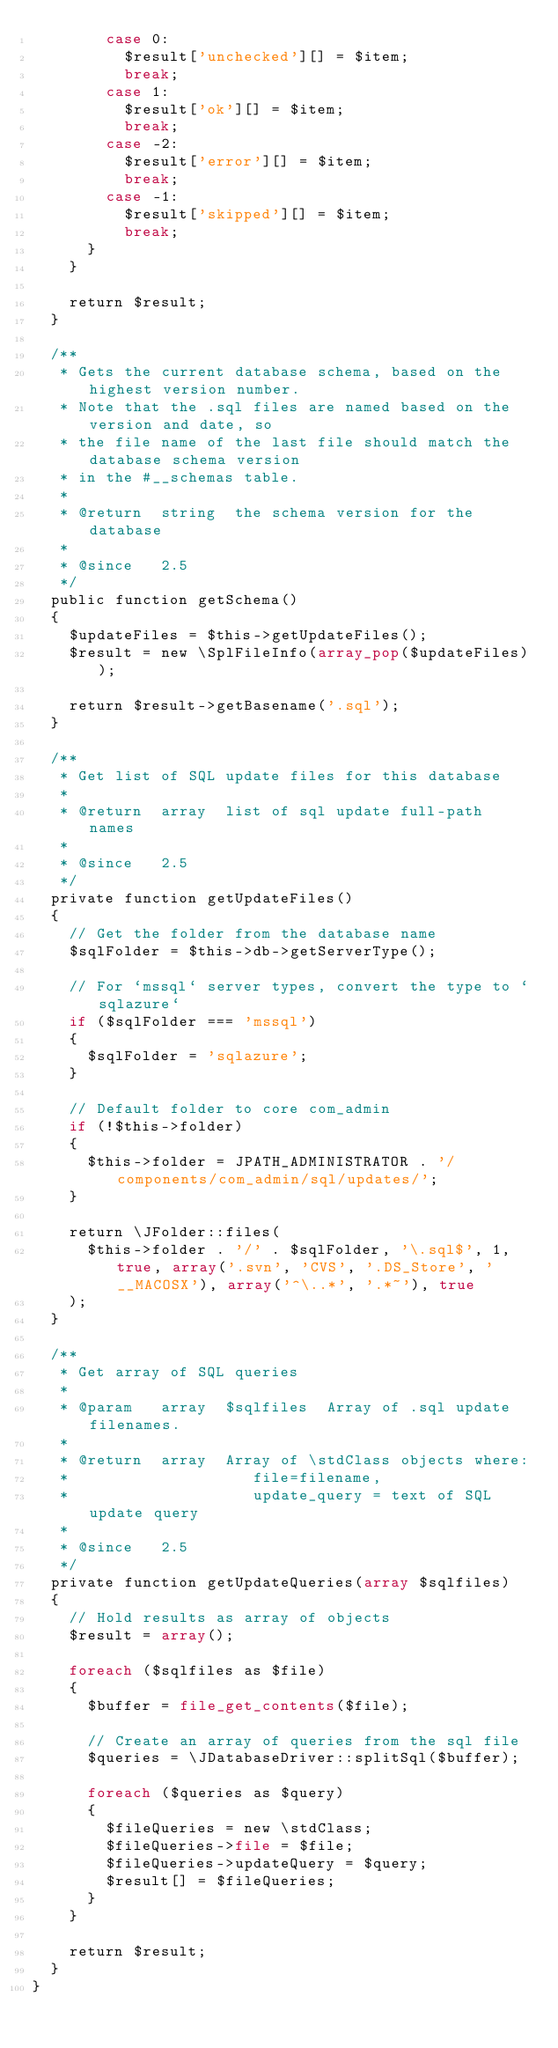<code> <loc_0><loc_0><loc_500><loc_500><_PHP_>				case 0:
					$result['unchecked'][] = $item;
					break;
				case 1:
					$result['ok'][] = $item;
					break;
				case -2:
					$result['error'][] = $item;
					break;
				case -1:
					$result['skipped'][] = $item;
					break;
			}
		}

		return $result;
	}

	/**
	 * Gets the current database schema, based on the highest version number.
	 * Note that the .sql files are named based on the version and date, so
	 * the file name of the last file should match the database schema version
	 * in the #__schemas table.
	 *
	 * @return  string  the schema version for the database
	 *
	 * @since   2.5
	 */
	public function getSchema()
	{
		$updateFiles = $this->getUpdateFiles();
		$result = new \SplFileInfo(array_pop($updateFiles));

		return $result->getBasename('.sql');
	}

	/**
	 * Get list of SQL update files for this database
	 *
	 * @return  array  list of sql update full-path names
	 *
	 * @since   2.5
	 */
	private function getUpdateFiles()
	{
		// Get the folder from the database name
		$sqlFolder = $this->db->getServerType();

		// For `mssql` server types, convert the type to `sqlazure`
		if ($sqlFolder === 'mssql')
		{
			$sqlFolder = 'sqlazure';
		}

		// Default folder to core com_admin
		if (!$this->folder)
		{
			$this->folder = JPATH_ADMINISTRATOR . '/components/com_admin/sql/updates/';
		}

		return \JFolder::files(
			$this->folder . '/' . $sqlFolder, '\.sql$', 1, true, array('.svn', 'CVS', '.DS_Store', '__MACOSX'), array('^\..*', '.*~'), true
		);
	}

	/**
	 * Get array of SQL queries
	 *
	 * @param   array  $sqlfiles  Array of .sql update filenames.
	 *
	 * @return  array  Array of \stdClass objects where:
	 *                    file=filename,
	 *                    update_query = text of SQL update query
	 *
	 * @since   2.5
	 */
	private function getUpdateQueries(array $sqlfiles)
	{
		// Hold results as array of objects
		$result = array();

		foreach ($sqlfiles as $file)
		{
			$buffer = file_get_contents($file);

			// Create an array of queries from the sql file
			$queries = \JDatabaseDriver::splitSql($buffer);

			foreach ($queries as $query)
			{
				$fileQueries = new \stdClass;
				$fileQueries->file = $file;
				$fileQueries->updateQuery = $query;
				$result[] = $fileQueries;
			}
		}

		return $result;
	}
}
</code> 